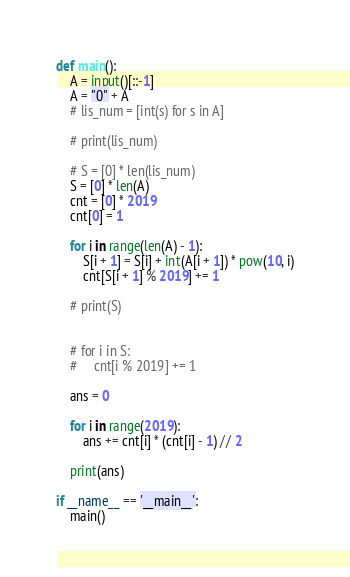<code> <loc_0><loc_0><loc_500><loc_500><_Python_>def main():
    A = input()[::-1]
    A = "0" + A
    # lis_num = [int(s) for s in A]

    # print(lis_num)

    # S = [0] * len(lis_num)
    S = [0] * len(A)
    cnt = [0] * 2019
    cnt[0] = 1

    for i in range(len(A) - 1):
        S[i + 1] = S[i] + int(A[i + 1]) * pow(10, i)
        cnt[S[i + 1] % 2019] += 1

    # print(S)


    # for i in S:
    #     cnt[i % 2019] += 1

    ans = 0

    for i in range(2019):
        ans += cnt[i] * (cnt[i] - 1) // 2

    print(ans)
    
if __name__ == '__main__':
    main()
</code> 